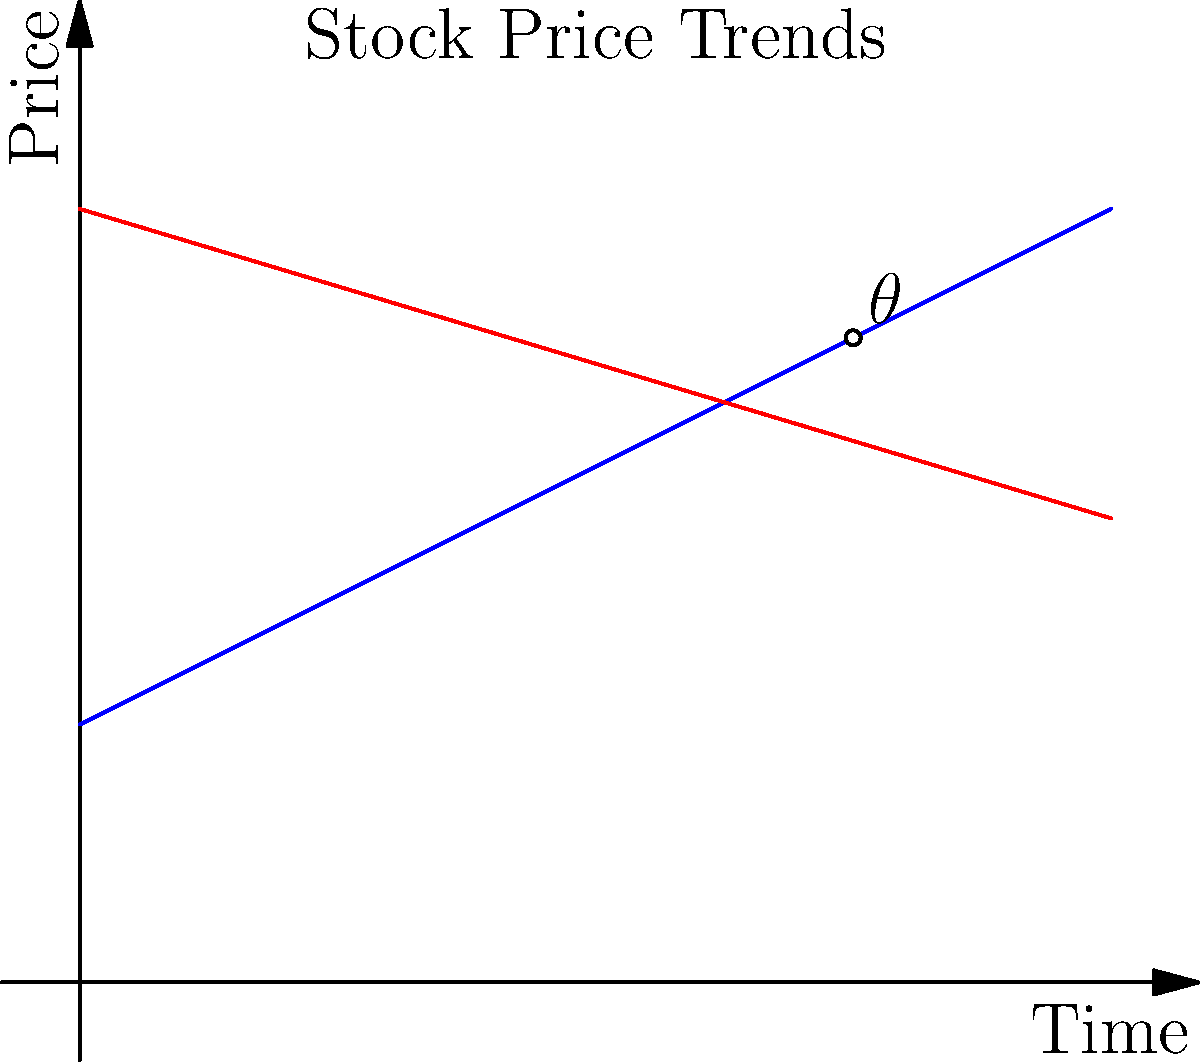In the stock price graph above, two trend lines intersect. Trend Line 1 has a slope of 0.5, while Trend Line 2 has a slope of -0.3. What is the angle $\theta$ (in degrees) between these two trend lines at their point of intersection? To find the angle between two intersecting lines, we can use the formula:

$$\tan \theta = \left|\frac{m_1 - m_2}{1 + m_1m_2}\right|$$

Where $m_1$ and $m_2$ are the slopes of the two lines.

Step 1: Identify the slopes
$m_1 = 0.5$ (Trend Line 1)
$m_2 = -0.3$ (Trend Line 2)

Step 2: Apply the formula
$$\tan \theta = \left|\frac{0.5 - (-0.3)}{1 + 0.5(-0.3)}\right| = \left|\frac{0.8}{0.85}\right| \approx 0.9412$$

Step 3: Calculate the angle using inverse tangent
$$\theta = \arctan(0.9412) \approx 43.3°$$

Step 4: Round to the nearest degree
$\theta \approx 43°$
Answer: 43° 